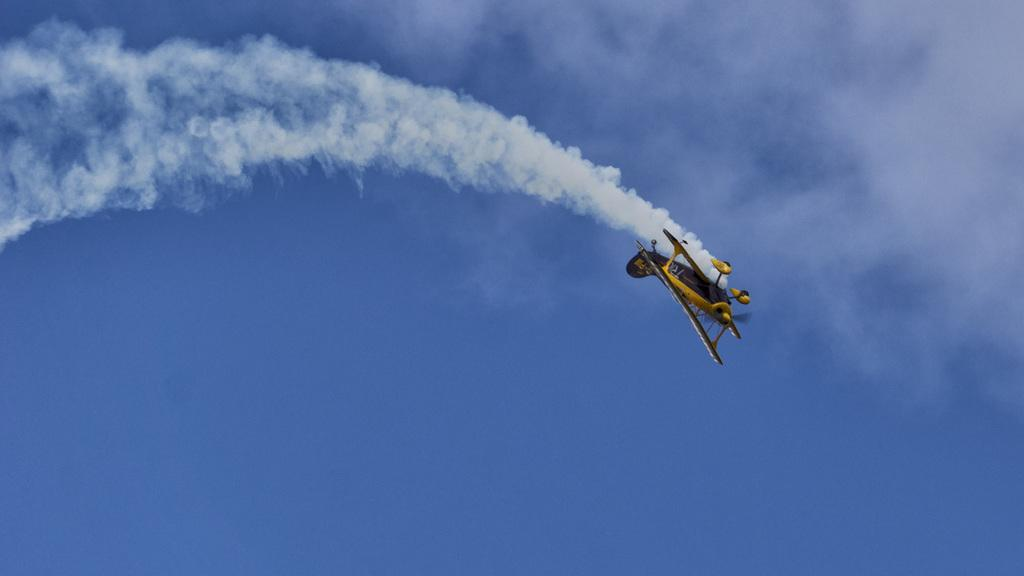What is the main subject of the image? The main subject of the image is an airplane. What is the airplane doing in the image? The airplane is flying in the sky. Can you describe any additional details about the airplane? Yes, the airplane is exhaling smoke. What type of stone can be seen being squeezed in the image? There is no stone present in the image; it features an airplane flying in the sky and exhaling smoke. What flavor of juice is being poured from the airplane in the image? There is no juice being poured from the airplane in the image; it is exhaling smoke while flying in the sky. 